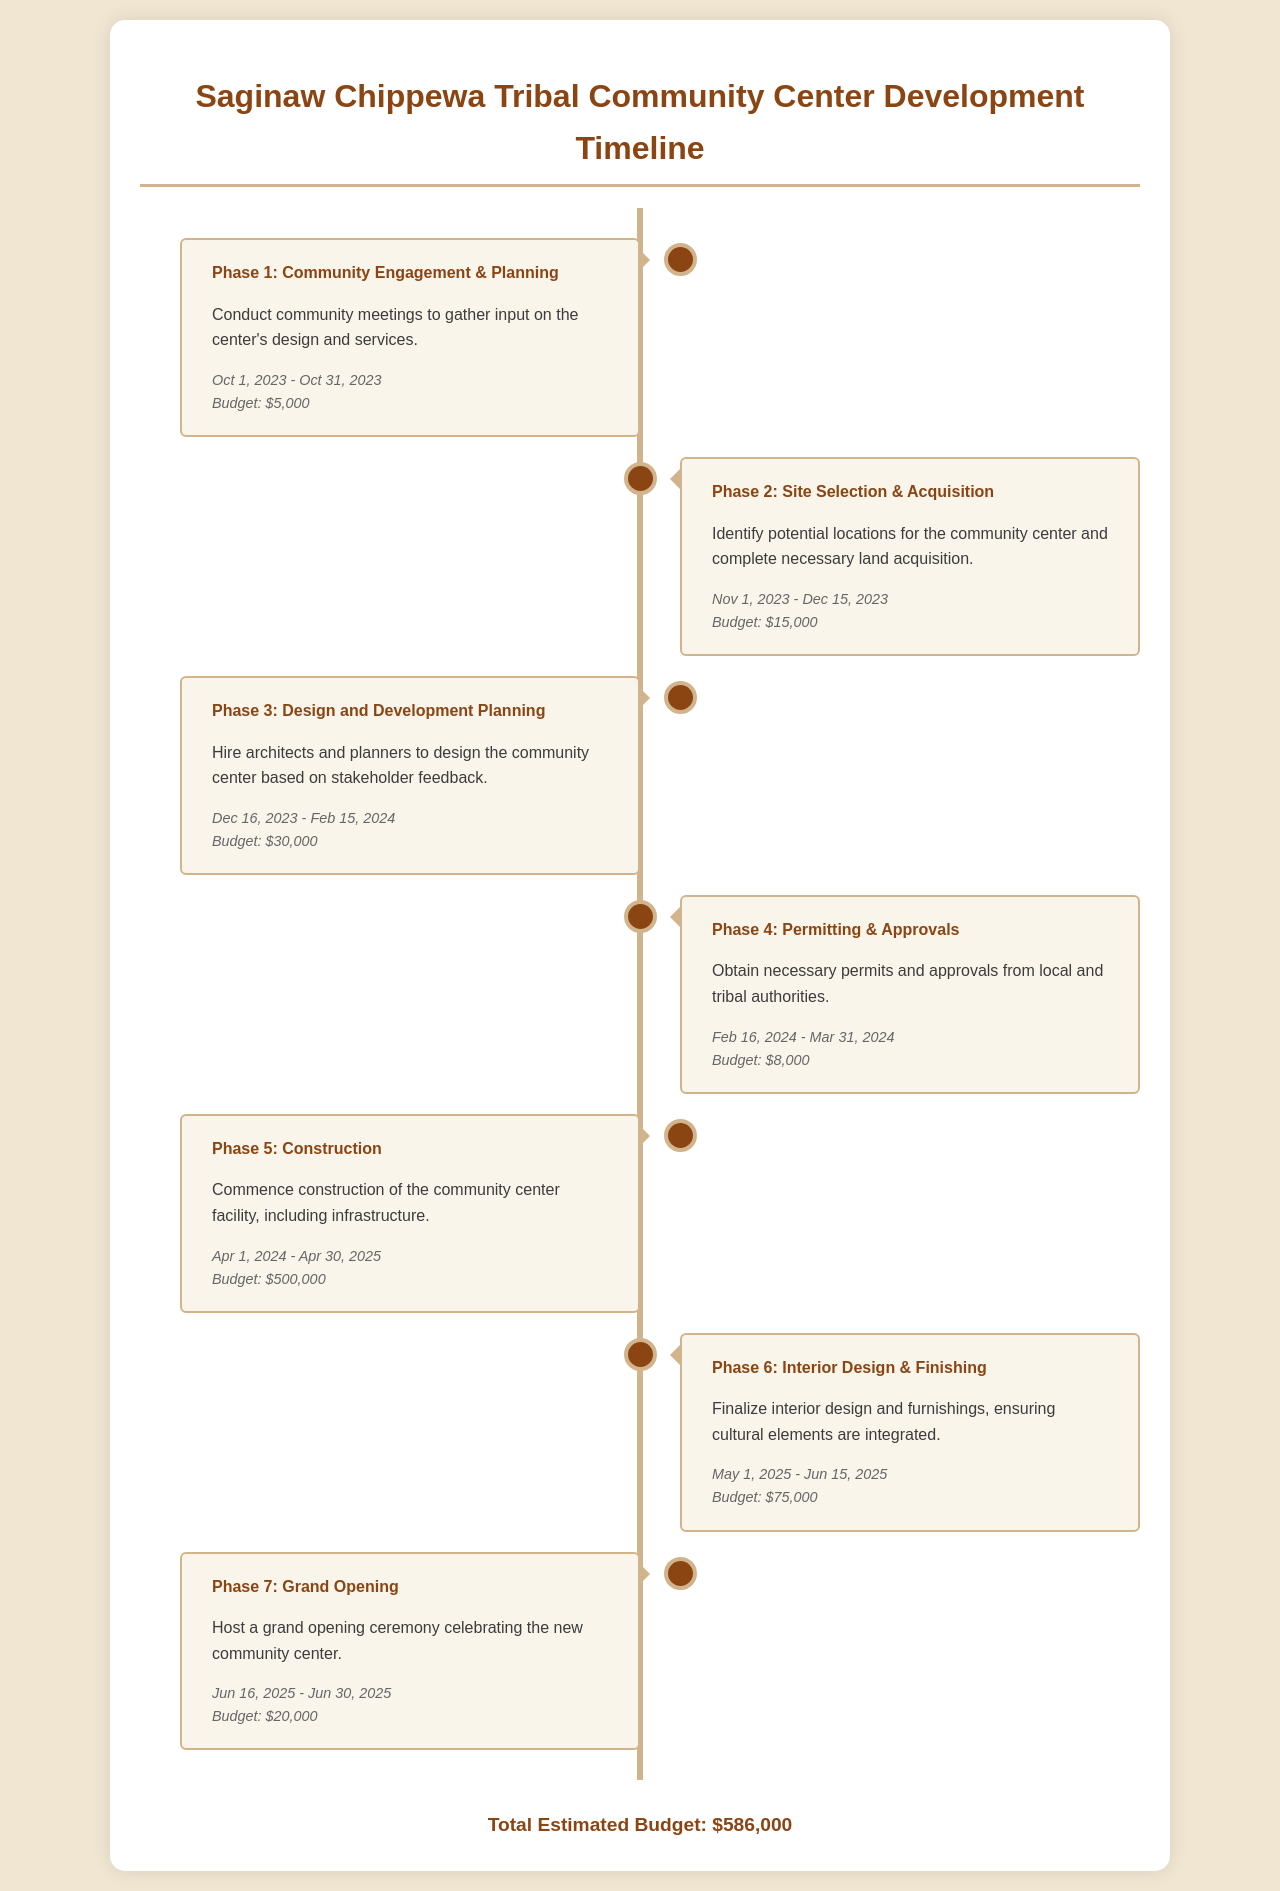What is the total estimated budget? The total estimated budget is presented at the end of the document summarizing the costs across all phases, which is $586,000.
Answer: $586,000 What is the start date for Phase 1? The document specifies the start and end dates of each phase; Phase 1 starts on October 1, 2023.
Answer: October 1, 2023 How much is allocated for Phase 3? The budget for each construction phase is individually mentioned; Phase 3 has a budget of $30,000.
Answer: $30,000 What is the purpose of Phase 6? The document outlines the task associated with each phase, and Phase 6 focuses on interior design and finishing.
Answer: Interior design & finishing When does Phase 5 commence? The starting date is provided in the timeline for each phase; Phase 5 begins on April 1, 2024.
Answer: April 1, 2024 How long does Phase 4 last? The duration is outlined in the schedule; Phase 4 starts on February 16, 2024, and ends on March 31, 2024, lasting for about 6 weeks.
Answer: 6 weeks What is included in the budget for Phase 2? Each phase has a specific budget listed distinctly; Phase 2 has a budget of $15,000.
Answer: $15,000 What event is scheduled for June 16, 2025? The timeline denotes specific activities for some phases; June 16, 2025, is marked for the grand opening ceremony.
Answer: Grand opening ceremony 